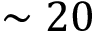Convert formula to latex. <formula><loc_0><loc_0><loc_500><loc_500>\sim 2 0</formula> 